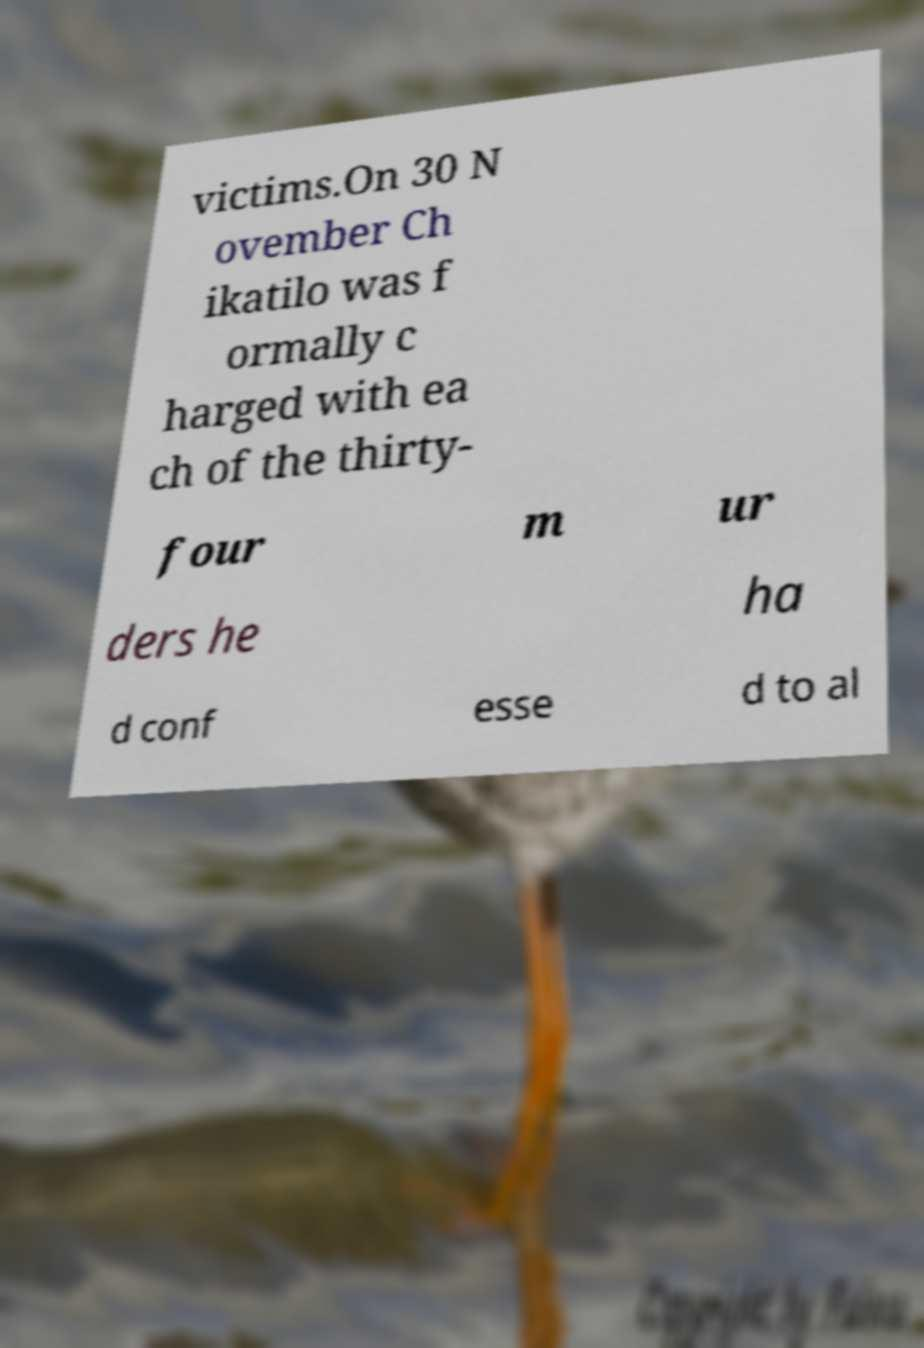What messages or text are displayed in this image? I need them in a readable, typed format. victims.On 30 N ovember Ch ikatilo was f ormally c harged with ea ch of the thirty- four m ur ders he ha d conf esse d to al 